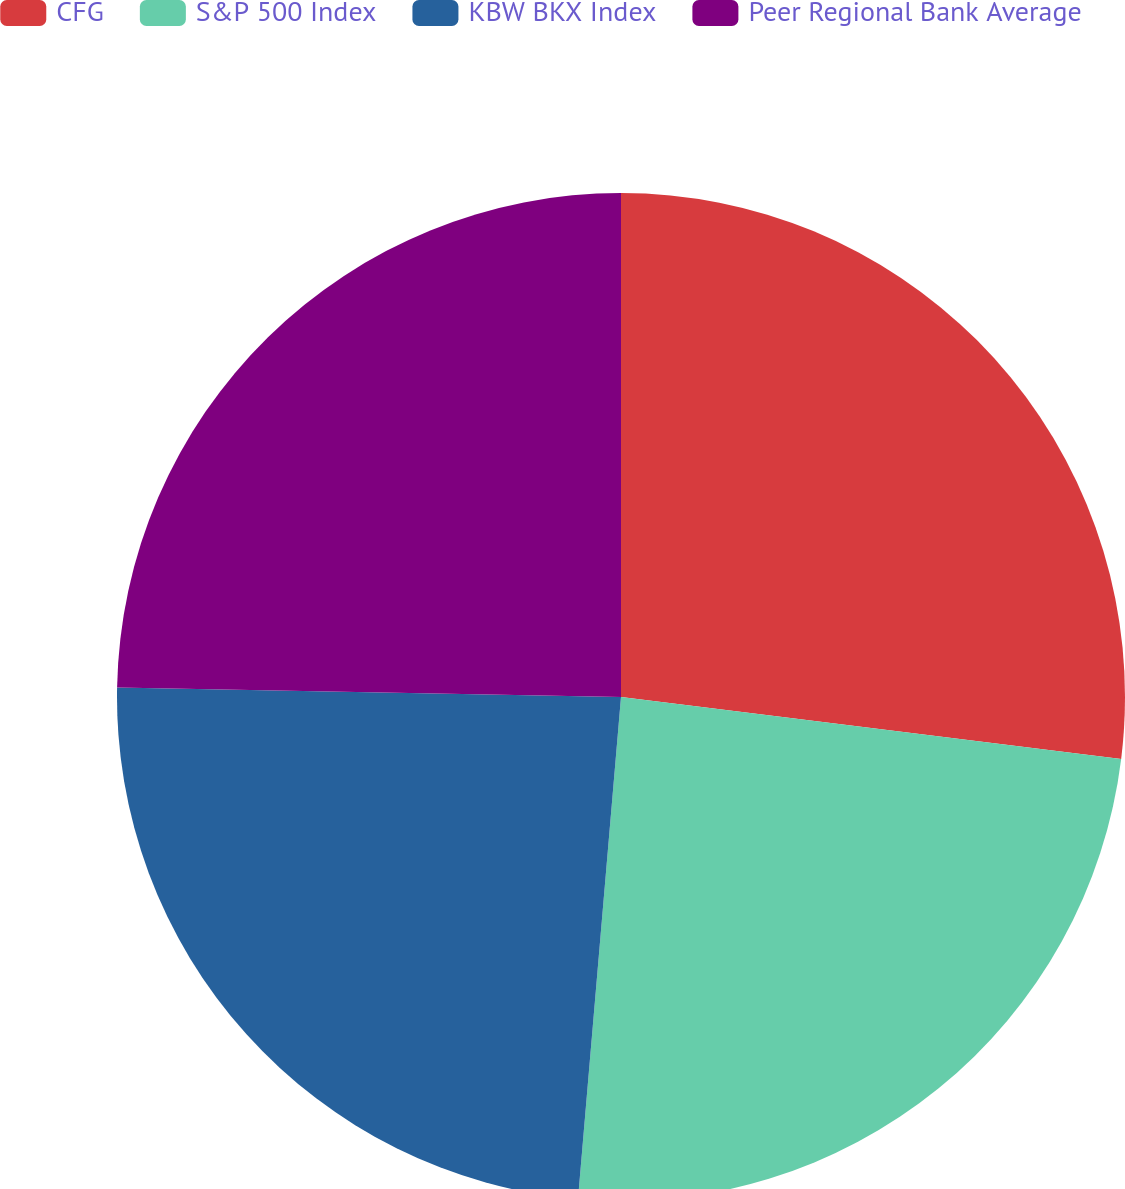Convert chart. <chart><loc_0><loc_0><loc_500><loc_500><pie_chart><fcel>CFG<fcel>S&P 500 Index<fcel>KBW BKX Index<fcel>Peer Regional Bank Average<nl><fcel>26.96%<fcel>24.4%<fcel>23.94%<fcel>24.7%<nl></chart> 